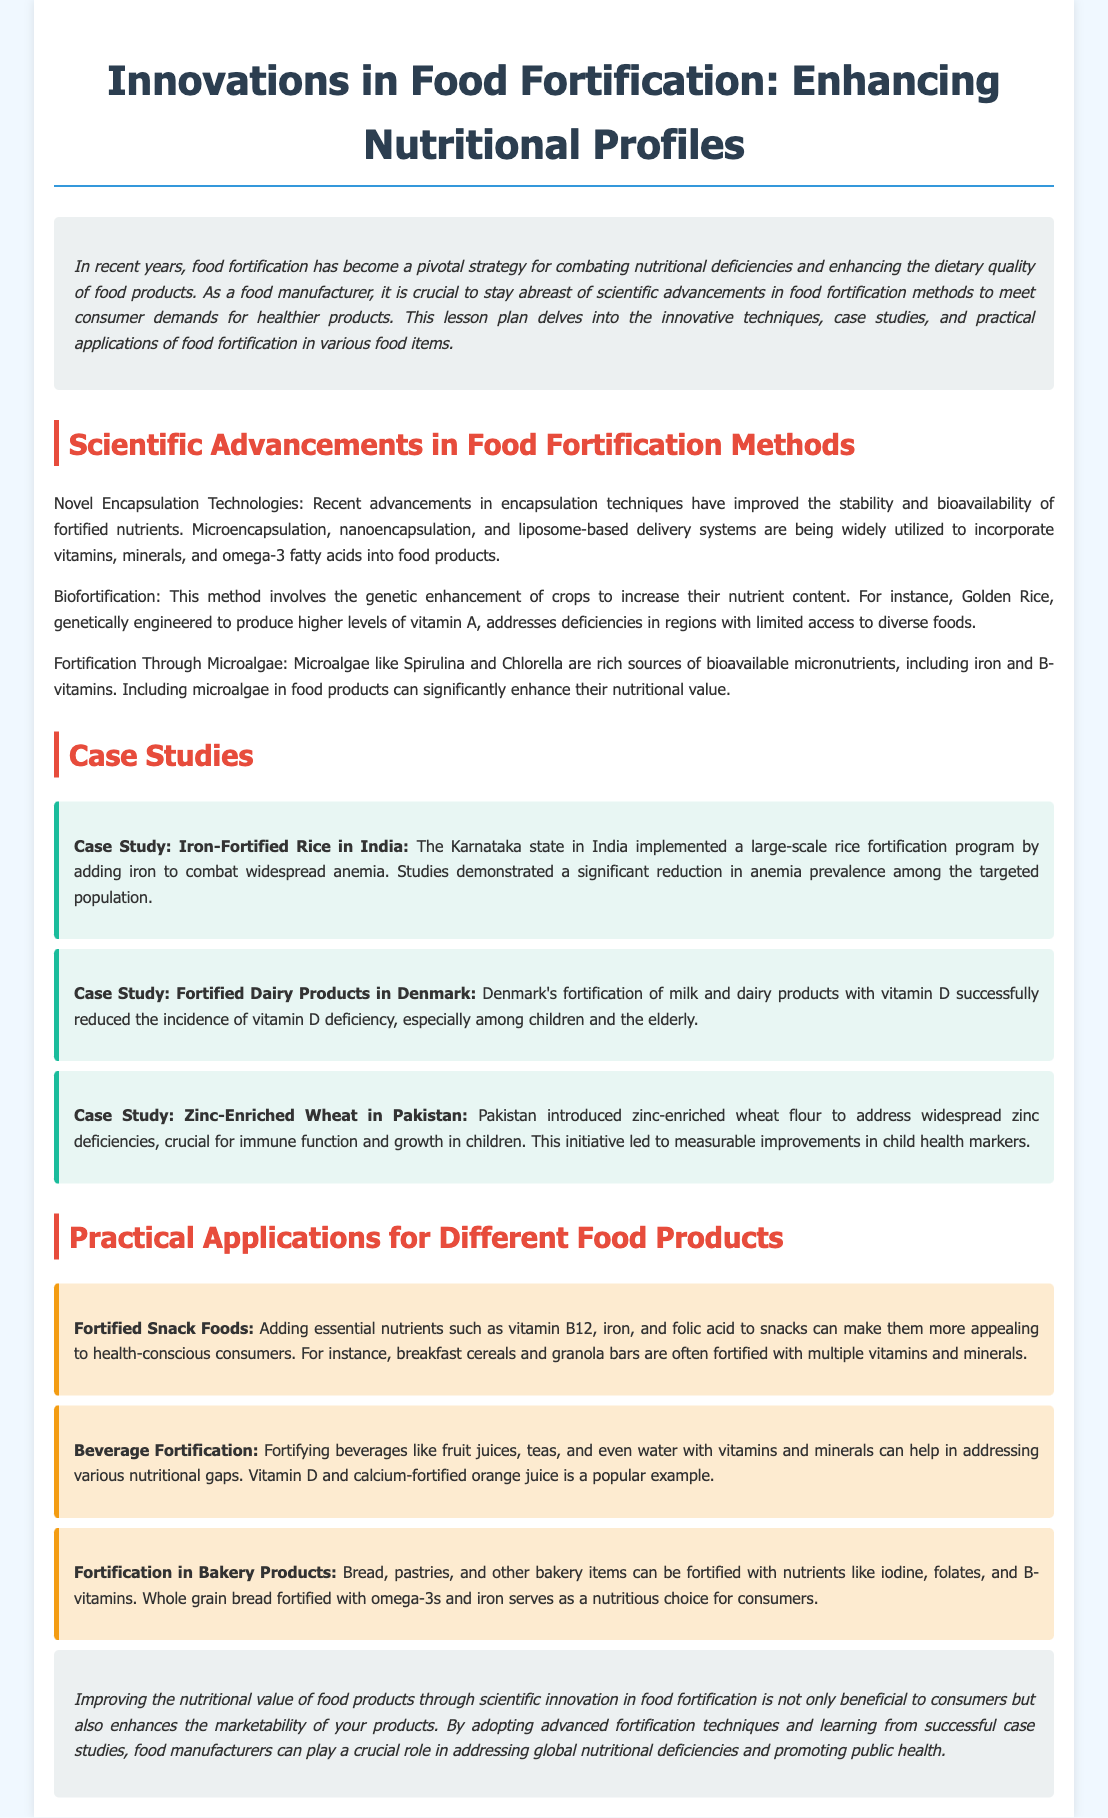what are the recent advancements in food fortification methods? The document mentions novel encapsulation technologies, biofortification, and fortification through microalgae as recent advancements.
Answer: novel encapsulation technologies, biofortification, fortification through microalgae what is a case study cited for iron-fortified rice? The document refers to a case study from Karnataka, India, which implemented a rice fortification program.
Answer: Karnataka, India which microalgae are mentioned as sources of bioavailable micronutrients? The document lists Spirulina and Chlorella as rich sources.
Answer: Spirulina, Chlorella how did Denmark address vitamin D deficiency? Denmark's approach involved fortifying milk and dairy products with vitamin D.
Answer: fortifying milk and dairy products with vitamin D what type of food product can be fortified with iodine and B-vitamins? The document states that bakery products like bread and pastries can be fortified with these nutrients.
Answer: bakery products what is the main benefit of improving nutritional value through fortification? The document indicates that it enhances the marketability of food products.
Answer: enhances marketability how does the case study involving Pakistan relate to zinc? Pakistan introduced zinc-enriched wheat flour to address zinc deficiencies.
Answer: zinc-enriched wheat flour which vitamins are mentioned for fortifying beverages? The document specifically mentions vitamin D and calcium for beverages.
Answer: vitamin D, calcium 